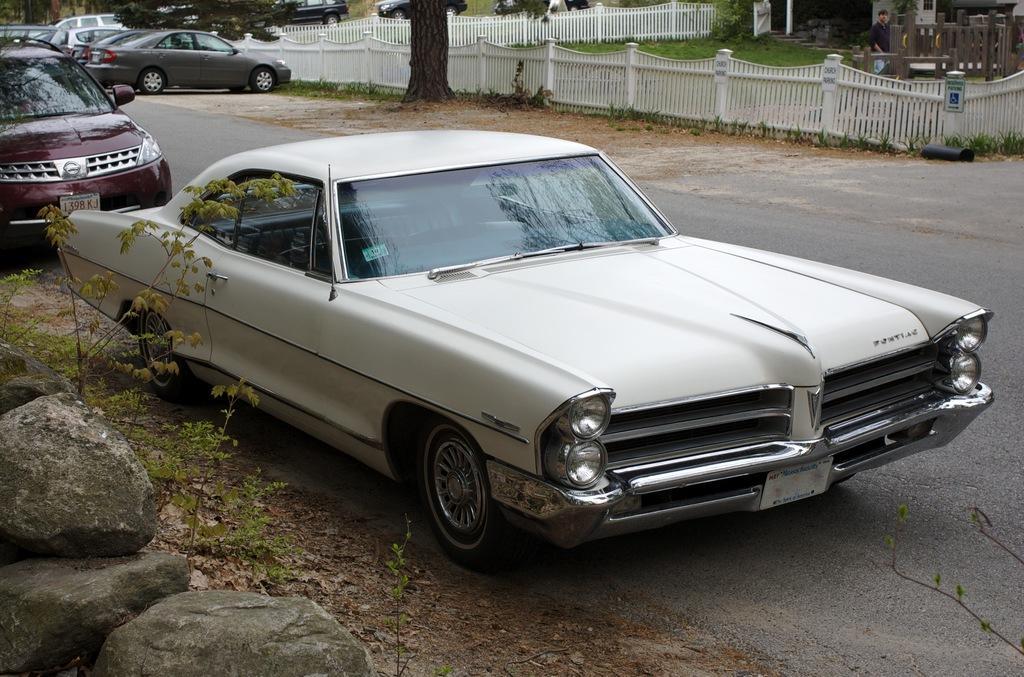Could you give a brief overview of what you see in this image? In this image at front there are cars on the road. Beside the cars there are rocks. At the background there are trees and we can see metal fencing was done. 